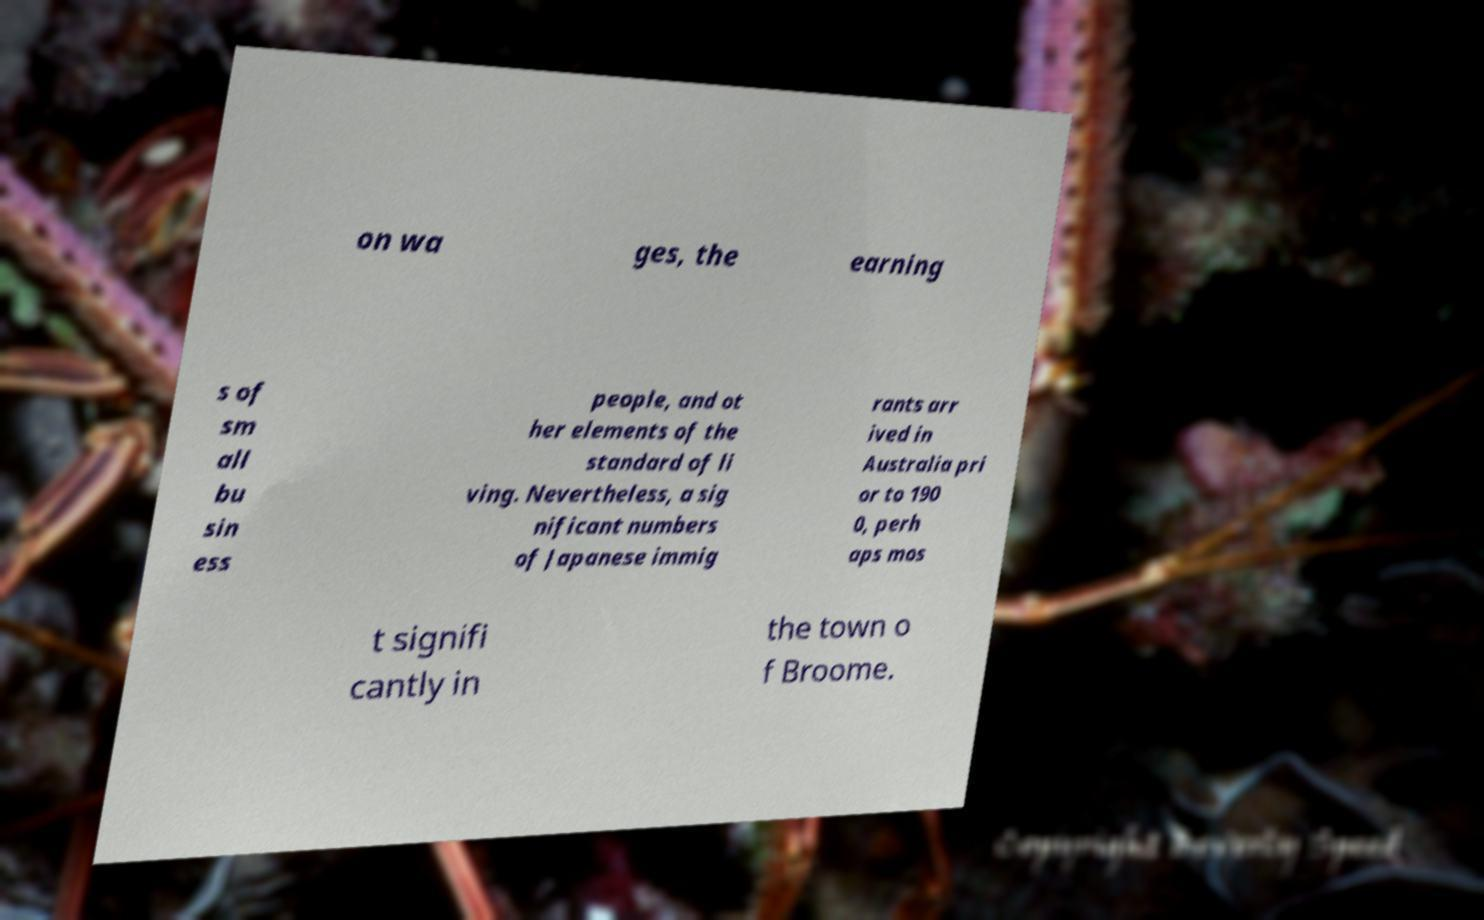Please read and relay the text visible in this image. What does it say? on wa ges, the earning s of sm all bu sin ess people, and ot her elements of the standard of li ving. Nevertheless, a sig nificant numbers of Japanese immig rants arr ived in Australia pri or to 190 0, perh aps mos t signifi cantly in the town o f Broome. 